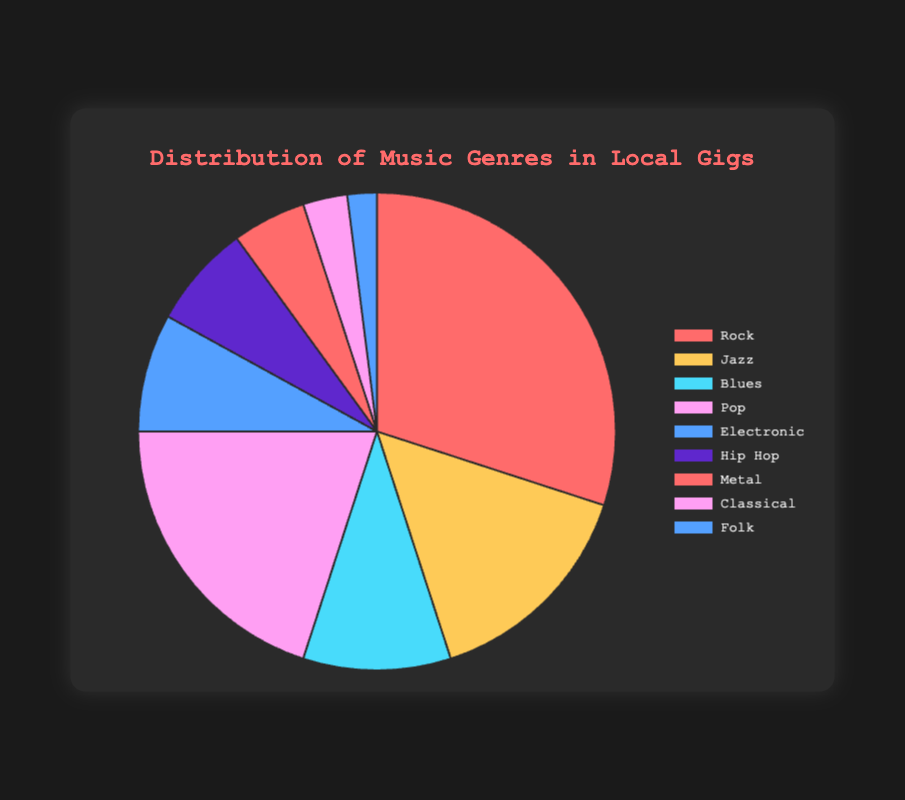What genre has the highest percentage? The genre with the highest percentage has the largest slice of the pie chart. By looking at the chart, Rock has the largest slice.
Answer: Rock Which genre has a greater percentage, Pop or Jazz? Compare the slices for Pop and Jazz. The Pop slice is larger, indicating it has a greater percentage.
Answer: Pop What is the combined percentage of Rock and Pop genres? Add the percentages for Rock (30%) and Pop (20%). 30% + 20% = 50%
Answer: 50% Which genres have a percentage less than 10%? Identify all slices that are smaller and labeled with percentages below 10%. The genres are Blues, Electronic, Hip Hop, Metal, Classical, and Folk.
Answer: Blues, Electronic, Hip Hop, Metal, Classical, Folk How much larger is the percentage of Rock compared to Classical? Subtract the percentage of Classical (3%) from Rock (30%). 30% - 3% = 27%
Answer: 27% What is the average percentage of the Jazz, Blues, and Folk genres? Add the percentages for Jazz (15%), Blues (10%), and Folk (2%), then divide by 3. (15% + 10% + 2%) / 3 = 9%
Answer: 9% What is the total percentage of all genres? Sum all percentages: 30% + 15% + 10% + 20% + 8% + 7% + 5% + 3% + 2% = 100%. This confirms the pie chart covers 100% of the genres.
Answer: 100% Which genre's slice is colored blue? Look at the color associated with each genre's slice. The Blues genre slice is the one colored blue.
Answer: Blues By what percentage does the genre Electronic fall short of the genre Pop? Subtract the percentage of Electronic (8%) from Pop (20%). 20% - 8% = 12%
Answer: 12% What's the difference in percentage between the top two most played genres? Identify the top two genres, Rock (30%) and Pop (20%). Subtract the smaller percentage from the larger one. 30% - 20% = 10%
Answer: 10% 